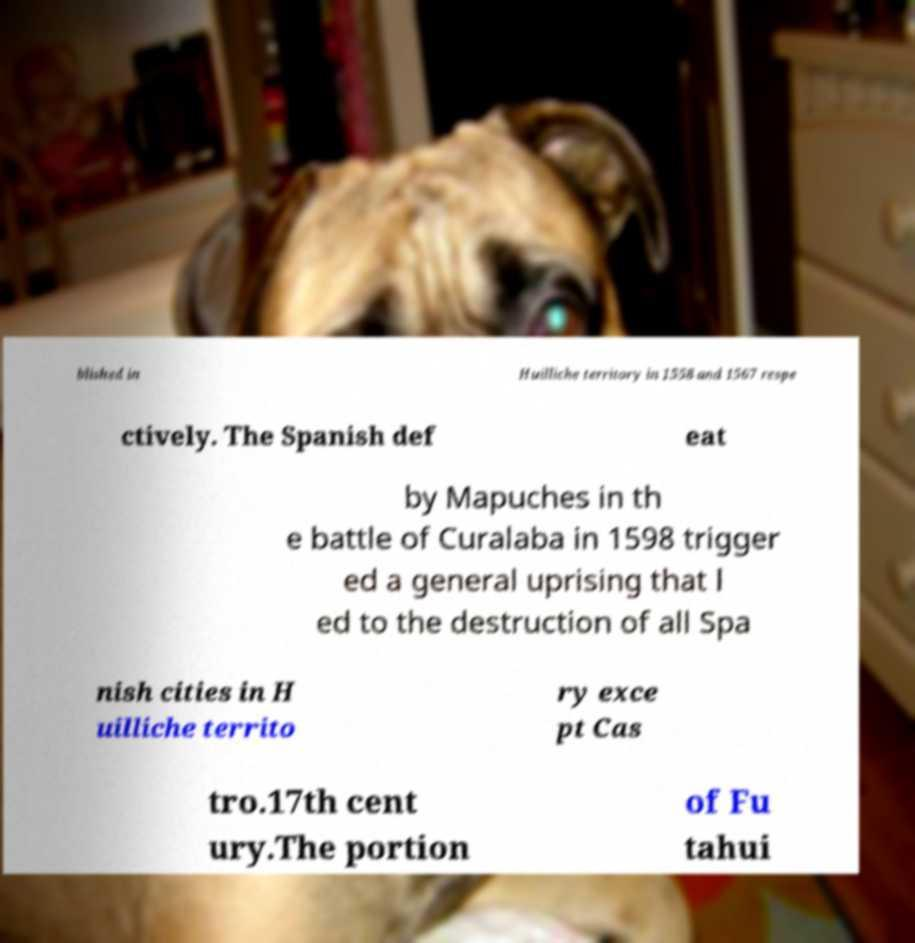There's text embedded in this image that I need extracted. Can you transcribe it verbatim? blished in Huilliche territory in 1558 and 1567 respe ctively. The Spanish def eat by Mapuches in th e battle of Curalaba in 1598 trigger ed a general uprising that l ed to the destruction of all Spa nish cities in H uilliche territo ry exce pt Cas tro.17th cent ury.The portion of Fu tahui 